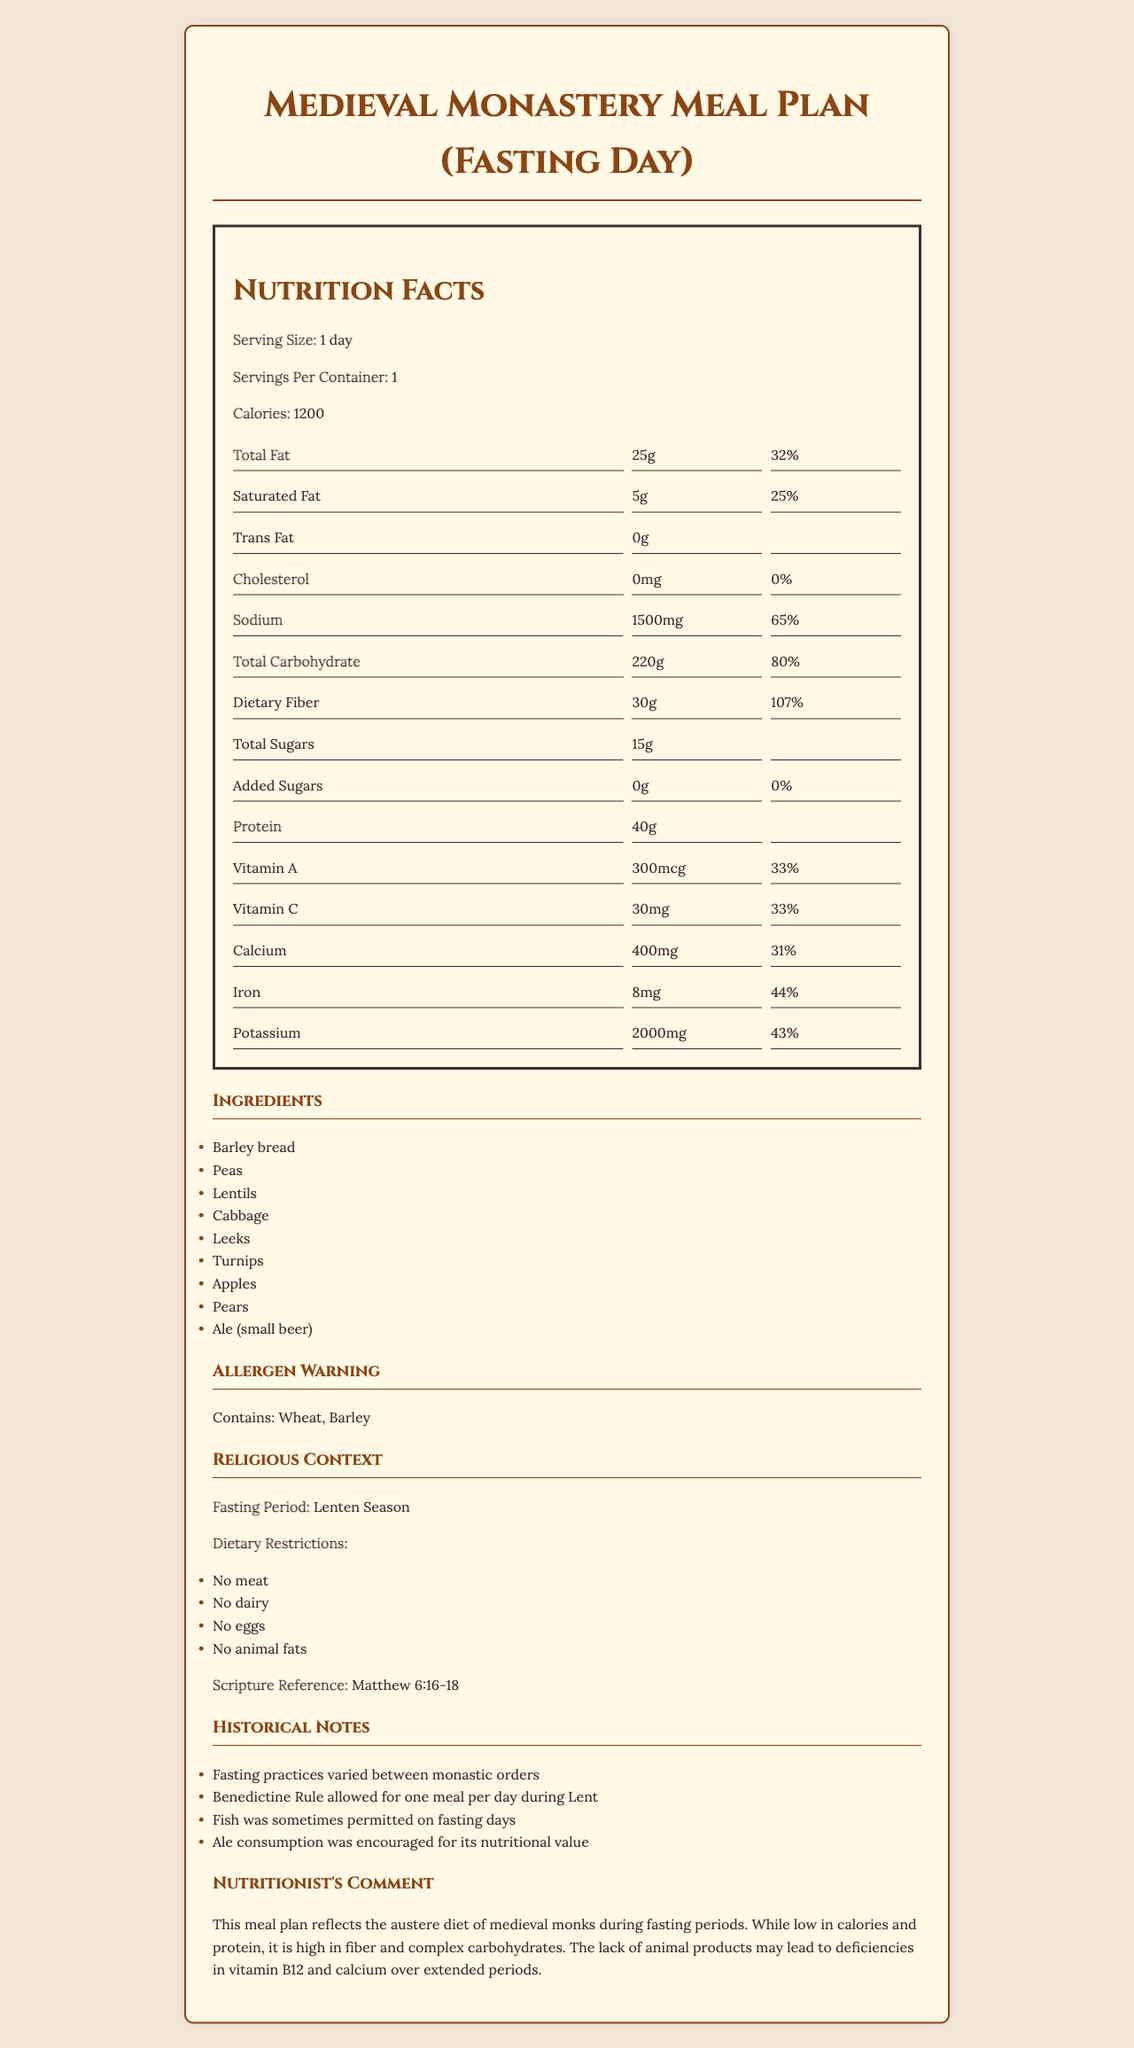what is the serving size? The serving size is specified as "1 day" in the document.
Answer: 1 day what is the main ingredient in the meal plan? The document's ingredients list begins with "Barley bread," suggesting it's a primary component.
Answer: Barley bread how many calories are in a serving? The calories per serving are listed as 1200 in the document.
Answer: 1200 what is the daily value percentage of total fat? The daily value percentage for total fat is 32%, as indicated in the nutrition facts.
Answer: 32% are there any added sugars in the meal plan? The document shows that the amount of added sugars is 0g, with a daily value percentage of 0%.
Answer: No which of the following periods was this meal plan designed for? A. Advent B. Ordinary Time C. Lenten Season D. Easter The religious context section specifies that the meal plan is for the "Lenten Season."
Answer: C. Lenten Season how much protein is in the meal plan? The nutrition facts indicate that there are 40 grams of protein in the meal plan.
Answer: 40g what dietary restrictions are mentioned in the document? The religious context lists these dietary restrictions under the dietary restrictions heading.
Answer: No meat, No dairy, No eggs, No animal fats how much dietary fiber does the meal plan contain? The dietary fiber amount is 30 grams, as stated in the nutrition facts.
Answer: 30g what types of food may lead to deficiencies in vitamin B12 and calcium? The nutritionist's comment notes that the lack of animal products may lead to deficiencies in vitamin B12 and calcium.
Answer: Lack of animal products how many servings per container are there? The document states that there is 1 serving per container.
Answer: 1 what does the scripture reference Matthew 6:16-18 relate to? A. Fasting practices B. Dietary restrictions C. Historical notes D. Nutritionist's comment The scripture reference is provided under the fasting period within the religious context.
Answer: A. Fasting practices true or false: the meal plan contains trans fat. The nutrition facts specify that the trans fat content is 0 grams.
Answer: False how much is the daily value percentage for iron in the meal plan? The daily value percentage for iron is stated as 44% in the nutrition facts.
Answer: 44% which of the following is an allergen in this meal plan? A. Eggs B. Milk C. Barley D. Fish The allergen warning section lists barley as a potential allergen.
Answer: C. Barley is the amount of sodium in the meal plan high compared to daily value percentage? The document states that the sodium amount is 1500mg, which is 65% of the daily value, considered to be high.
Answer: Yes what were the fasting practices of Benedictine Rule during Lent? The historical notes state that the Benedictine Rule allowed for one meal per day during Lent.
Answer: One meal per day describe the main idea of the document. This meal plan includes ingredients like barley bread, peas, and cabbage, complies with dietary restrictions such as no meat or dairy, and provides nutritional information, including calories, proteins, and fats. Historical notes and a nutritionist's comment offer additional context.
Answer: The document details the nutrition facts of a medieval monastery's meal plan for fasting days, highlighting specific dietary restrictions adhered to during the Lenten season. what other beverages, aside from ale, are mentioned as part of the meal plan? The document only mentions ale (small beer) and does not provide information on additional beverages.
Answer: Not enough information 